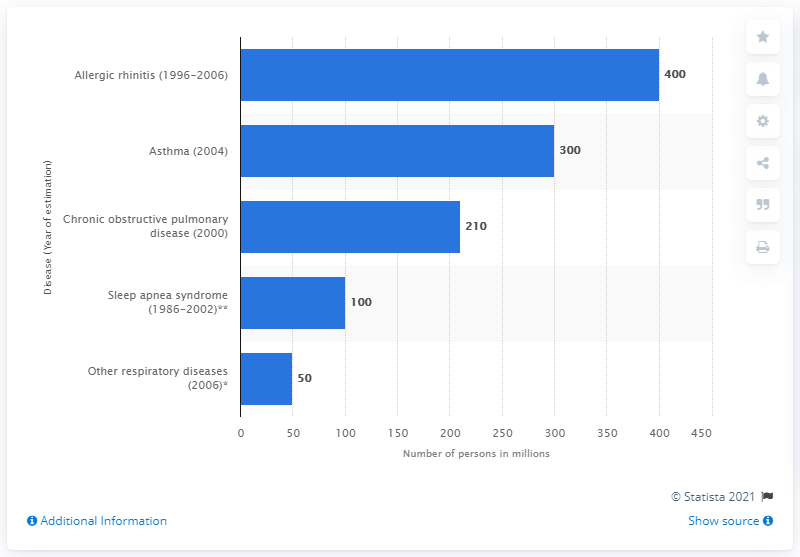Mention a couple of crucial points in this snapshot. According to estimates, in 2007, it is estimated that worldwide, approximately 300 million people suffered from asthma. 